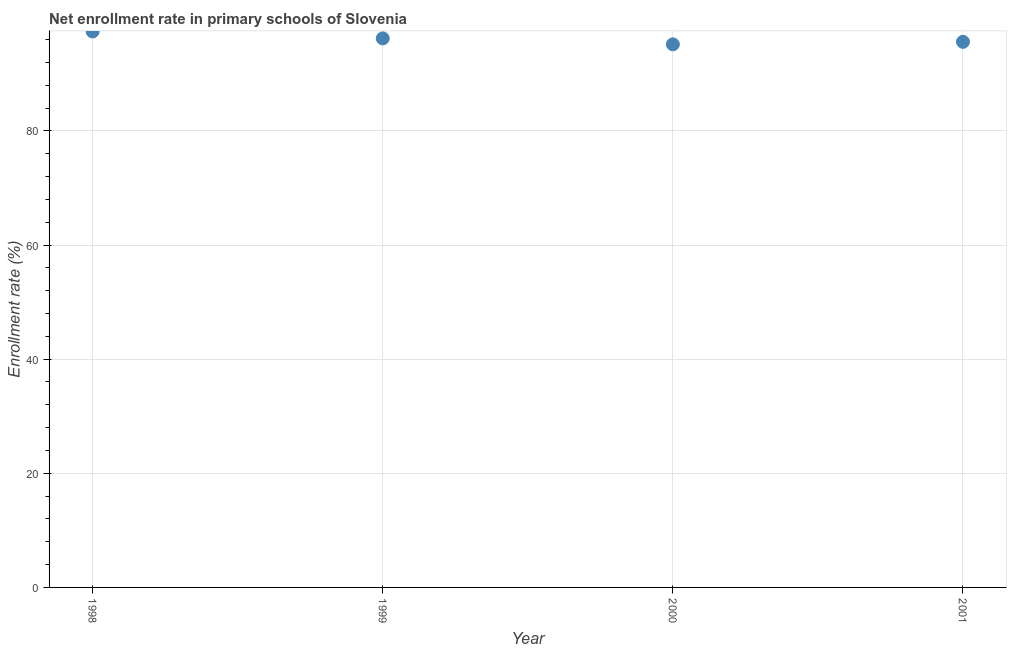What is the net enrollment rate in primary schools in 1998?
Your answer should be very brief. 97.42. Across all years, what is the maximum net enrollment rate in primary schools?
Make the answer very short. 97.42. Across all years, what is the minimum net enrollment rate in primary schools?
Your answer should be very brief. 95.16. What is the sum of the net enrollment rate in primary schools?
Keep it short and to the point. 384.39. What is the difference between the net enrollment rate in primary schools in 1998 and 2000?
Provide a succinct answer. 2.25. What is the average net enrollment rate in primary schools per year?
Offer a very short reply. 96.1. What is the median net enrollment rate in primary schools?
Keep it short and to the point. 95.9. What is the ratio of the net enrollment rate in primary schools in 1999 to that in 2000?
Your response must be concise. 1.01. Is the difference between the net enrollment rate in primary schools in 1999 and 2000 greater than the difference between any two years?
Your answer should be compact. No. What is the difference between the highest and the second highest net enrollment rate in primary schools?
Keep it short and to the point. 1.21. Is the sum of the net enrollment rate in primary schools in 1998 and 2000 greater than the maximum net enrollment rate in primary schools across all years?
Make the answer very short. Yes. What is the difference between the highest and the lowest net enrollment rate in primary schools?
Keep it short and to the point. 2.25. In how many years, is the net enrollment rate in primary schools greater than the average net enrollment rate in primary schools taken over all years?
Keep it short and to the point. 2. Does the graph contain any zero values?
Give a very brief answer. No. What is the title of the graph?
Keep it short and to the point. Net enrollment rate in primary schools of Slovenia. What is the label or title of the X-axis?
Offer a very short reply. Year. What is the label or title of the Y-axis?
Your response must be concise. Enrollment rate (%). What is the Enrollment rate (%) in 1998?
Keep it short and to the point. 97.42. What is the Enrollment rate (%) in 1999?
Your answer should be very brief. 96.21. What is the Enrollment rate (%) in 2000?
Your answer should be very brief. 95.16. What is the Enrollment rate (%) in 2001?
Provide a succinct answer. 95.6. What is the difference between the Enrollment rate (%) in 1998 and 1999?
Provide a succinct answer. 1.21. What is the difference between the Enrollment rate (%) in 1998 and 2000?
Provide a succinct answer. 2.25. What is the difference between the Enrollment rate (%) in 1998 and 2001?
Your response must be concise. 1.82. What is the difference between the Enrollment rate (%) in 1999 and 2000?
Your response must be concise. 1.04. What is the difference between the Enrollment rate (%) in 1999 and 2001?
Provide a succinct answer. 0.6. What is the difference between the Enrollment rate (%) in 2000 and 2001?
Your answer should be very brief. -0.44. What is the ratio of the Enrollment rate (%) in 1998 to that in 2000?
Offer a very short reply. 1.02. What is the ratio of the Enrollment rate (%) in 1998 to that in 2001?
Offer a terse response. 1.02. What is the ratio of the Enrollment rate (%) in 1999 to that in 2000?
Provide a succinct answer. 1.01. What is the ratio of the Enrollment rate (%) in 1999 to that in 2001?
Provide a succinct answer. 1.01. What is the ratio of the Enrollment rate (%) in 2000 to that in 2001?
Your response must be concise. 0.99. 